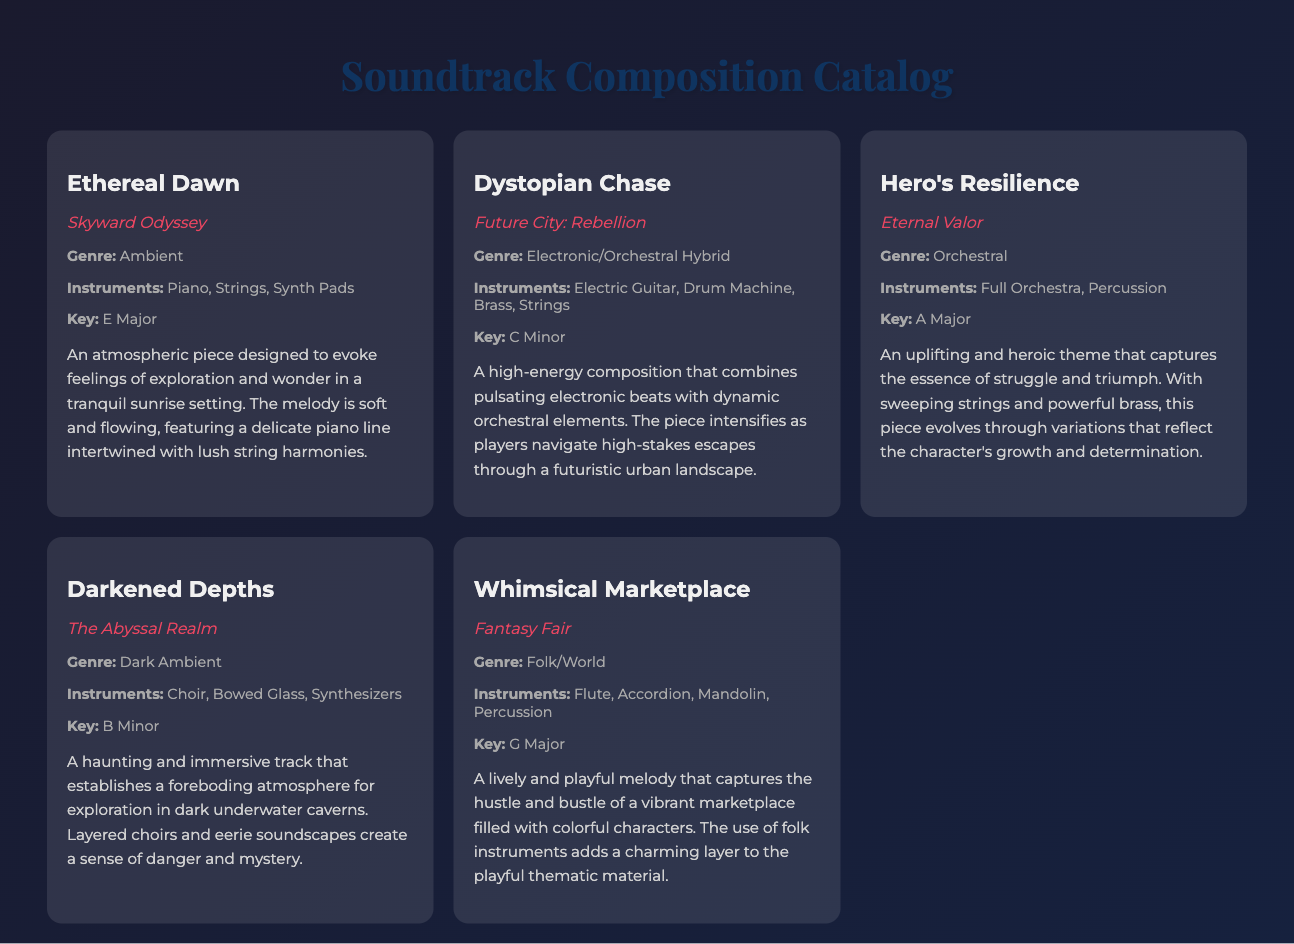What is the title of the composition in the game "Skyward Odyssey"? The title is listed prominently along with the respective game, which is "Ethereal Dawn."
Answer: Ethereal Dawn What genre does the composition "Hero's Resilience" belong to? Genres are specified in the details section for each composition, with "Hero's Resilience" categorized as "Orchestral."
Answer: Orchestral What instruments are used in "Dystopian Chase"? Instruments are mentioned under the details for each composition; "Dystopian Chase" includes Electric Guitar, Drum Machine, Brass, and Strings.
Answer: Electric Guitar, Drum Machine, Brass, Strings What key is "Darkened Depths" composed in? The key is explicitly provided in the details section, which states that "Darkened Depths" is in B Minor.
Answer: B Minor Which composition features a lively and playful melody? This description is provided in the context of "Whimsical Marketplace," which captures the atmosphere of a marketplace.
Answer: Whimsical Marketplace How many compositions are mentioned in the document? Counting all distinctly listed compositions results in a total of five.
Answer: Five What atmosphere does "Ethereal Dawn" aim to evoke? The composition aims to evoke feelings of exploration and wonder in a tranquil sunrise setting.
Answer: Exploration and wonder What instrument is primarily featured in "Whimsical Marketplace"? The primary instruments mentioned include Flute and Accordion, among others; the Flute stands out in the context.
Answer: Flute In which game does "Darkened Depths" appear? This is clearly stated, associating the title with the game "The Abyssal Realm."
Answer: The Abyssal Realm 